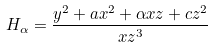<formula> <loc_0><loc_0><loc_500><loc_500>H _ { \alpha } = \frac { y ^ { 2 } + a x ^ { 2 } + \alpha x z + c z ^ { 2 } } { x z ^ { 3 } }</formula> 